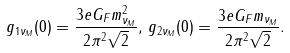<formula> <loc_0><loc_0><loc_500><loc_500>g _ { 1 \nu _ { M } } ( 0 ) = \frac { 3 e G _ { F } m _ { \nu _ { M } } ^ { 2 } } { 2 \pi ^ { 2 } \sqrt { 2 } } , \, g _ { 2 \nu _ { M } } ( 0 ) = \frac { 3 e G _ { F } m _ { \nu _ { M } } } { 2 \pi ^ { 2 } \sqrt { 2 } } .</formula> 